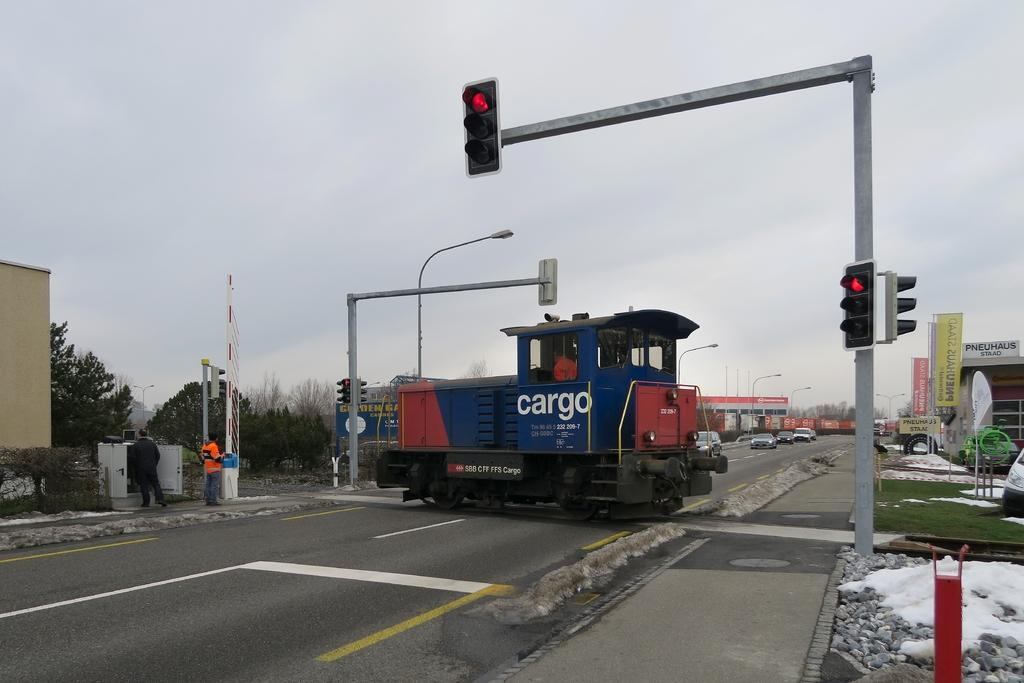Provide a one-sentence caption for the provided image. The train on the tracks crossing a road is a cargo train. 